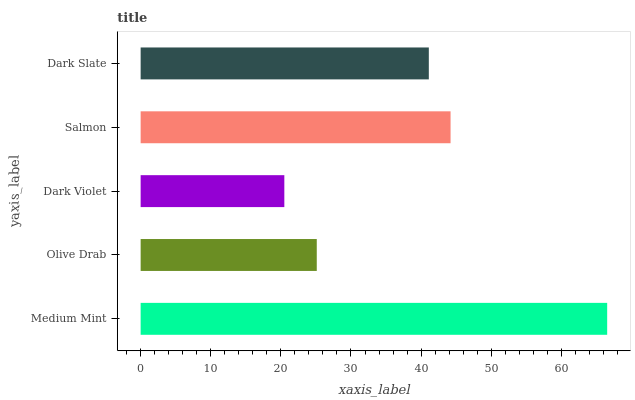Is Dark Violet the minimum?
Answer yes or no. Yes. Is Medium Mint the maximum?
Answer yes or no. Yes. Is Olive Drab the minimum?
Answer yes or no. No. Is Olive Drab the maximum?
Answer yes or no. No. Is Medium Mint greater than Olive Drab?
Answer yes or no. Yes. Is Olive Drab less than Medium Mint?
Answer yes or no. Yes. Is Olive Drab greater than Medium Mint?
Answer yes or no. No. Is Medium Mint less than Olive Drab?
Answer yes or no. No. Is Dark Slate the high median?
Answer yes or no. Yes. Is Dark Slate the low median?
Answer yes or no. Yes. Is Olive Drab the high median?
Answer yes or no. No. Is Dark Violet the low median?
Answer yes or no. No. 